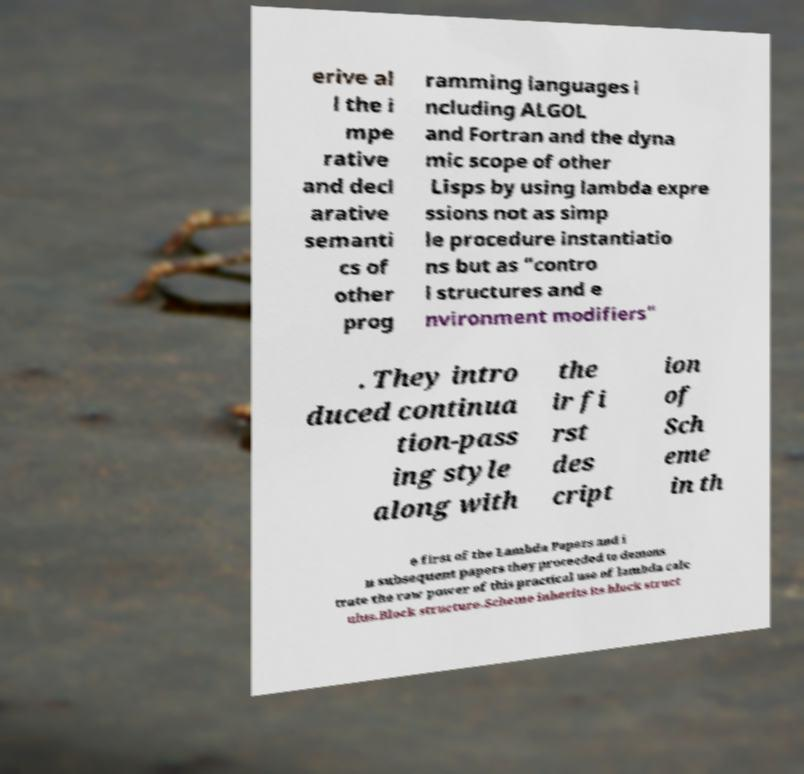There's text embedded in this image that I need extracted. Can you transcribe it verbatim? erive al l the i mpe rative and decl arative semanti cs of other prog ramming languages i ncluding ALGOL and Fortran and the dyna mic scope of other Lisps by using lambda expre ssions not as simp le procedure instantiatio ns but as "contro l structures and e nvironment modifiers" . They intro duced continua tion-pass ing style along with the ir fi rst des cript ion of Sch eme in th e first of the Lambda Papers and i n subsequent papers they proceeded to demons trate the raw power of this practical use of lambda calc ulus.Block structure.Scheme inherits its block struct 